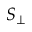Convert formula to latex. <formula><loc_0><loc_0><loc_500><loc_500>S _ { \perp }</formula> 